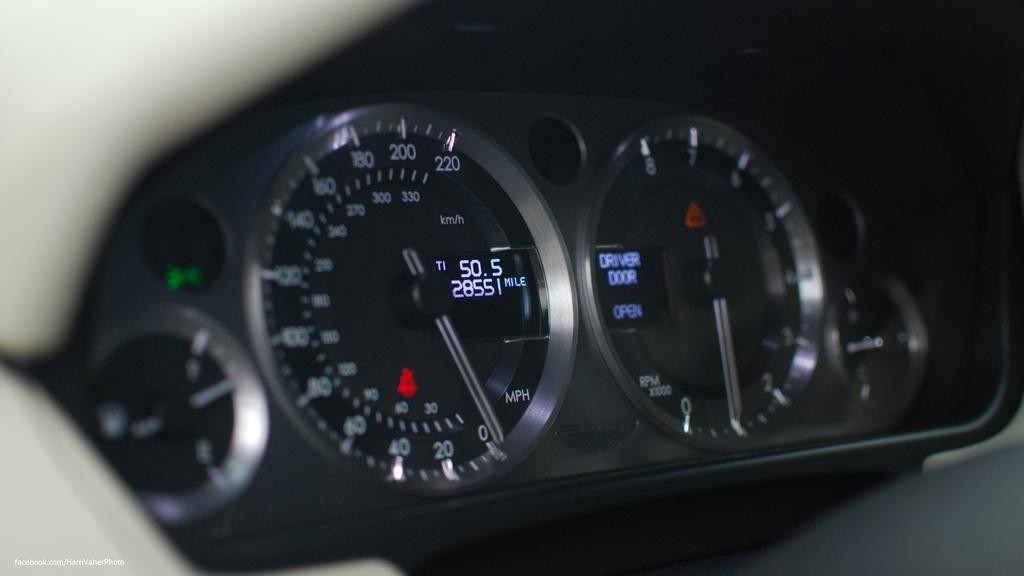What is the main object in the image? There is a digital meter in the image. What type of device is the digital meter part of? The digital meter belongs to a vehicle. How many zippers can be seen on the digital meter in the image? There are no zippers present on the digital meter in the image, as it is an electronic device. 